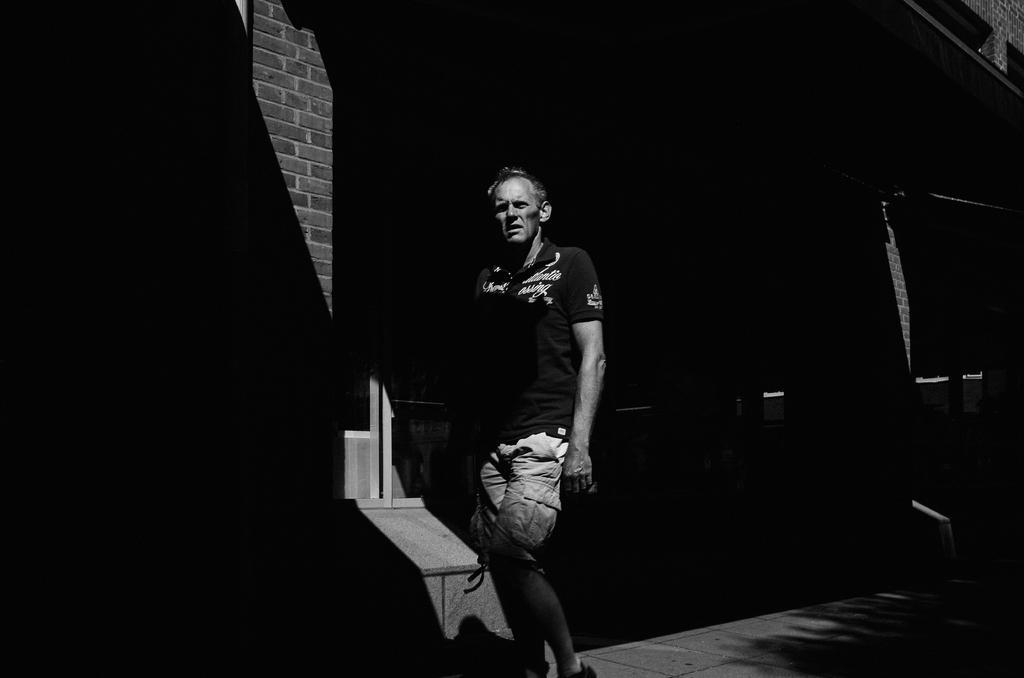Can you describe this image briefly? There is a person in a t-shirt walking on a footpath. In the background, there is a building which is having brick wall. 